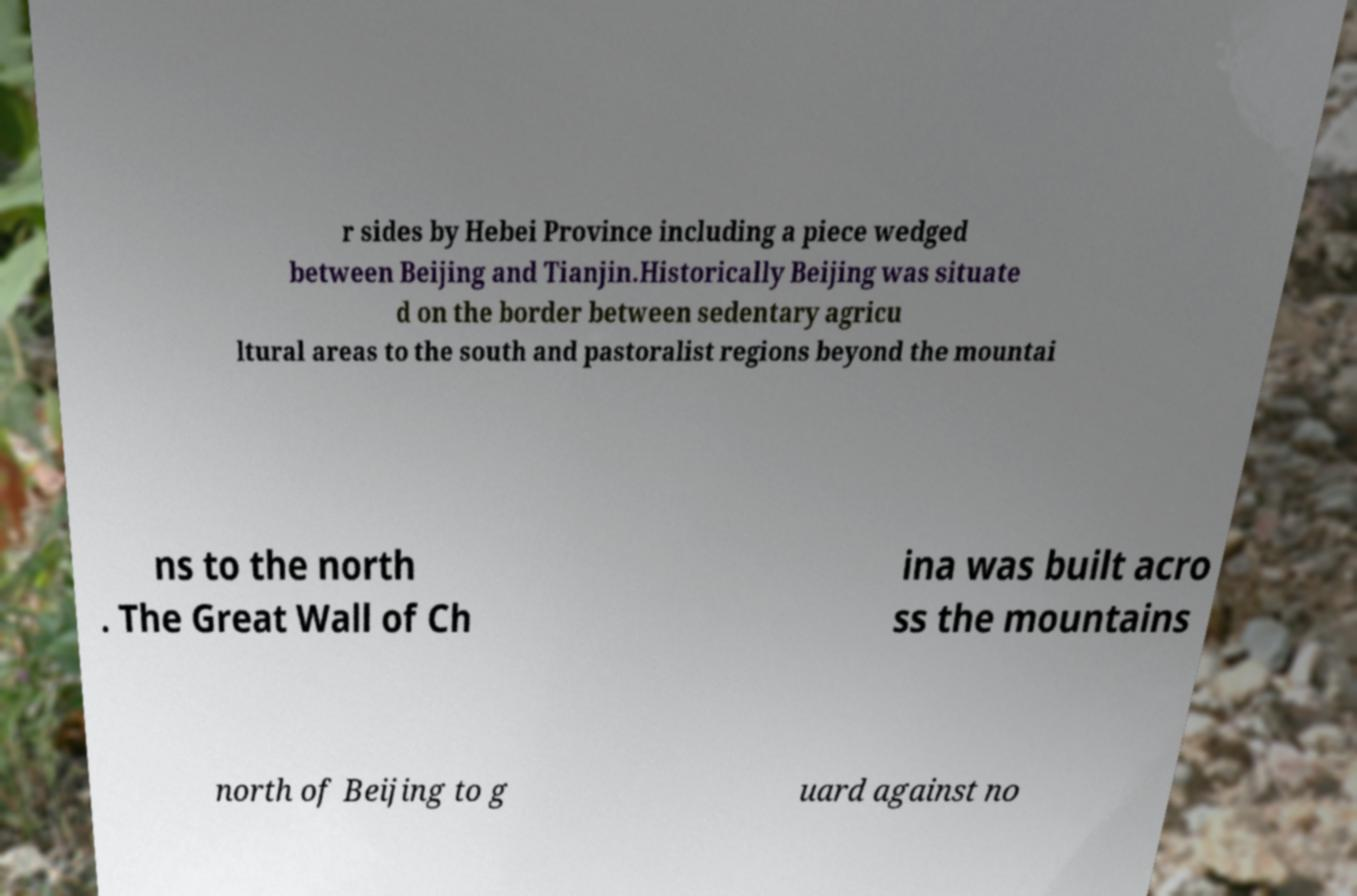There's text embedded in this image that I need extracted. Can you transcribe it verbatim? r sides by Hebei Province including a piece wedged between Beijing and Tianjin.Historically Beijing was situate d on the border between sedentary agricu ltural areas to the south and pastoralist regions beyond the mountai ns to the north . The Great Wall of Ch ina was built acro ss the mountains north of Beijing to g uard against no 